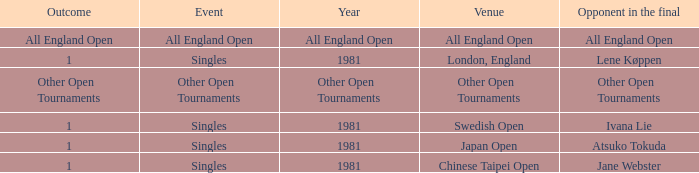What is the rival in the final round with an all england open conclusion? All England Open. 